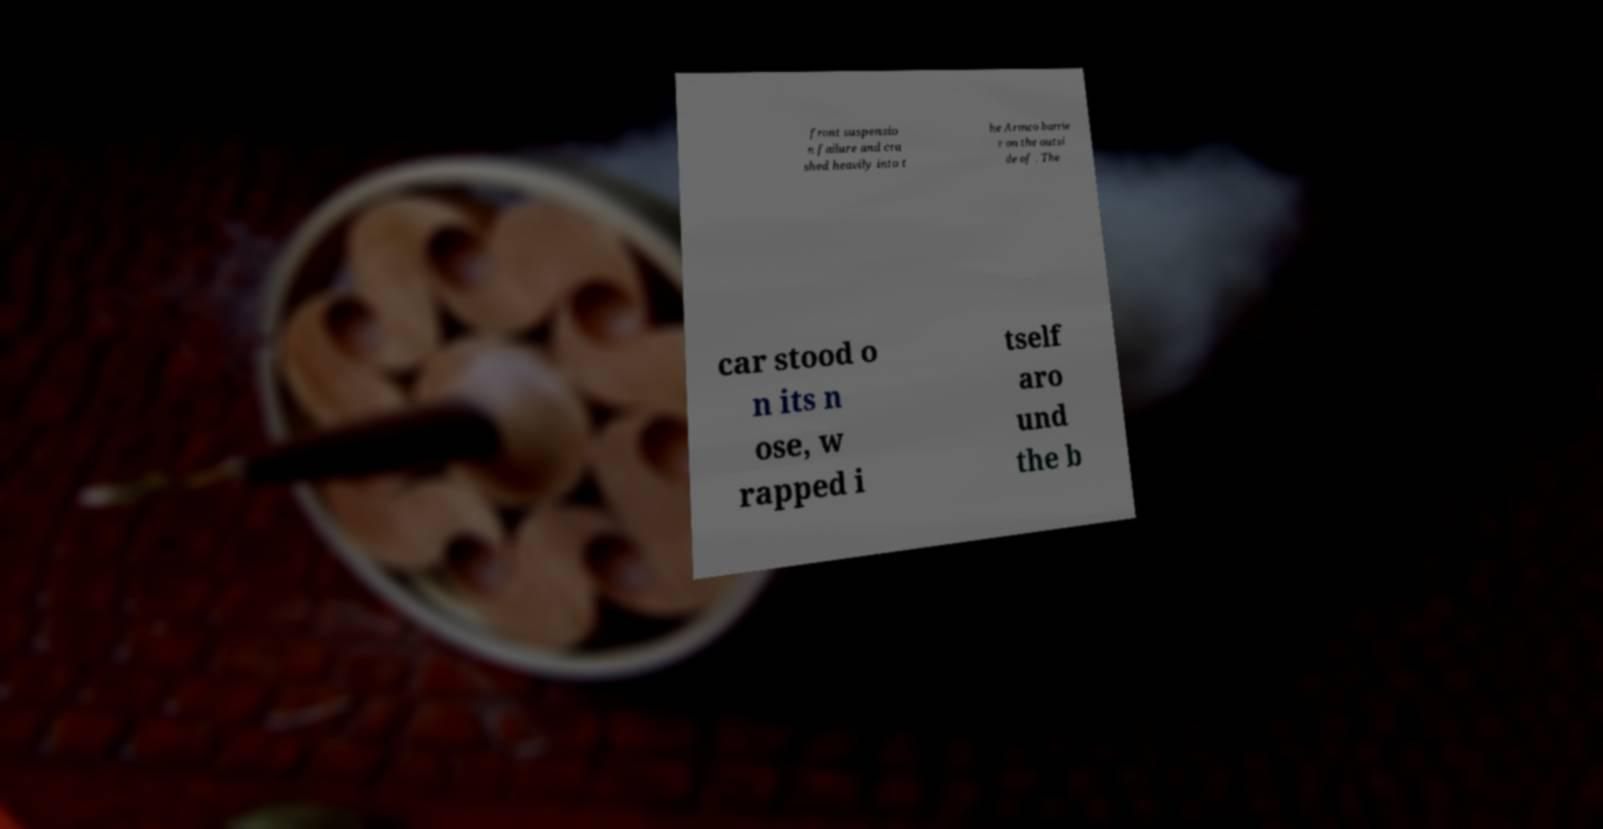For documentation purposes, I need the text within this image transcribed. Could you provide that? front suspensio n failure and cra shed heavily into t he Armco barrie r on the outsi de of . The car stood o n its n ose, w rapped i tself aro und the b 